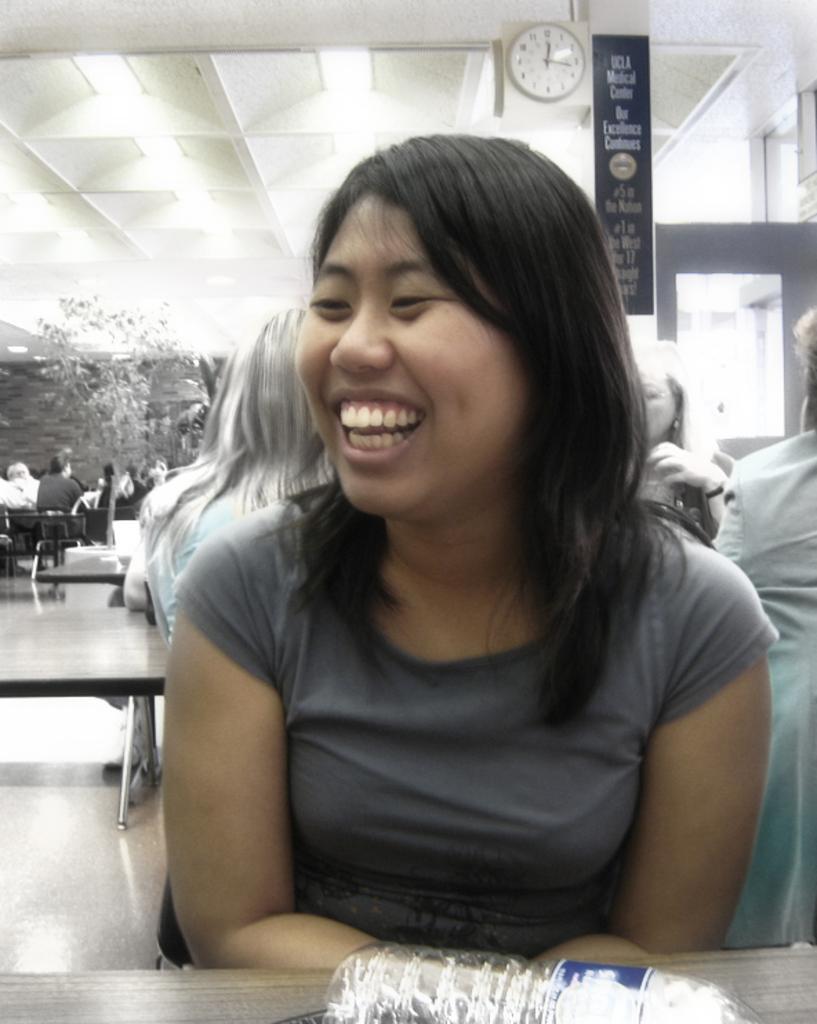Please provide a concise description of this image. In this image I can see a woman wearing grey colored dress is sitting in front of a table and on the table I can see a bottle. In the background I can see few other persons sitting, few trees, a black colored banner, the ceiling, few lights to the ceiling and a clock which is white in color. 